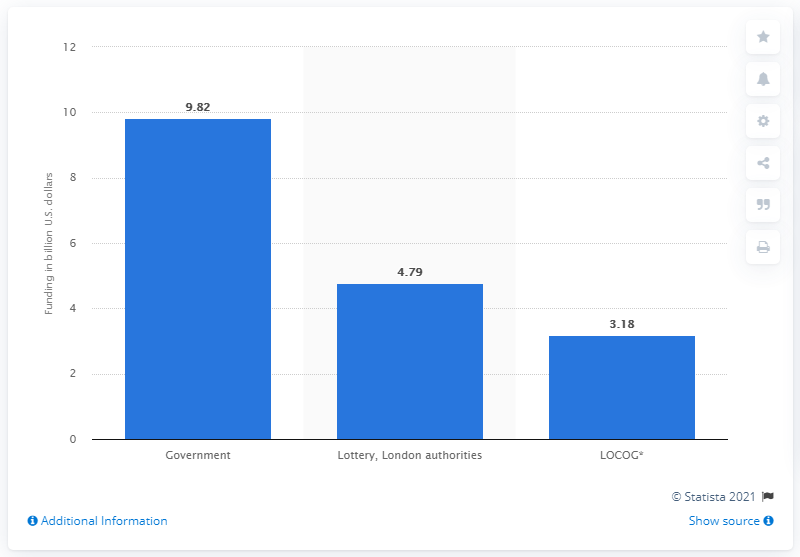Give some essential details in this illustration. The London Organising Committee contributes a certain amount of money to the overall budget of the Olympics. 